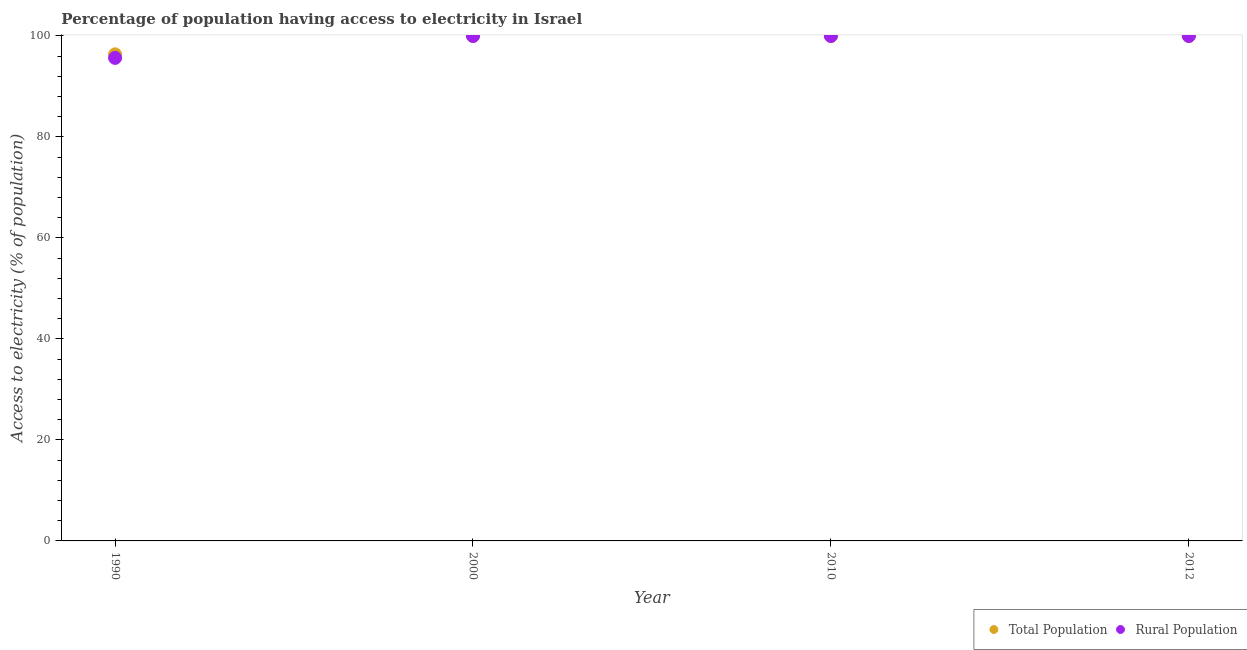How many different coloured dotlines are there?
Give a very brief answer. 2. Across all years, what is the minimum percentage of population having access to electricity?
Keep it short and to the point. 96.36. In which year was the percentage of rural population having access to electricity maximum?
Ensure brevity in your answer.  2000. What is the total percentage of population having access to electricity in the graph?
Provide a succinct answer. 396.36. What is the difference between the percentage of population having access to electricity in 2012 and the percentage of rural population having access to electricity in 2000?
Offer a terse response. 0. What is the average percentage of rural population having access to electricity per year?
Your answer should be very brief. 98.92. In the year 1990, what is the difference between the percentage of rural population having access to electricity and percentage of population having access to electricity?
Your response must be concise. -0.7. In how many years, is the percentage of rural population having access to electricity greater than 56 %?
Your answer should be very brief. 4. What is the difference between the highest and the lowest percentage of rural population having access to electricity?
Provide a succinct answer. 4.34. In how many years, is the percentage of population having access to electricity greater than the average percentage of population having access to electricity taken over all years?
Offer a terse response. 3. Does the percentage of rural population having access to electricity monotonically increase over the years?
Your response must be concise. No. Is the percentage of rural population having access to electricity strictly greater than the percentage of population having access to electricity over the years?
Your answer should be very brief. No. Are the values on the major ticks of Y-axis written in scientific E-notation?
Your answer should be compact. No. Does the graph contain grids?
Keep it short and to the point. No. How are the legend labels stacked?
Your answer should be very brief. Horizontal. What is the title of the graph?
Give a very brief answer. Percentage of population having access to electricity in Israel. What is the label or title of the Y-axis?
Your answer should be compact. Access to electricity (% of population). What is the Access to electricity (% of population) of Total Population in 1990?
Keep it short and to the point. 96.36. What is the Access to electricity (% of population) in Rural Population in 1990?
Provide a short and direct response. 95.66. What is the Access to electricity (% of population) of Total Population in 2000?
Make the answer very short. 100. What is the Access to electricity (% of population) in Rural Population in 2000?
Give a very brief answer. 100. What is the Access to electricity (% of population) in Total Population in 2010?
Provide a succinct answer. 100. What is the Access to electricity (% of population) of Rural Population in 2010?
Provide a succinct answer. 100. What is the Access to electricity (% of population) in Total Population in 2012?
Offer a very short reply. 100. What is the Access to electricity (% of population) in Rural Population in 2012?
Your answer should be very brief. 100. Across all years, what is the maximum Access to electricity (% of population) of Total Population?
Your answer should be compact. 100. Across all years, what is the minimum Access to electricity (% of population) in Total Population?
Make the answer very short. 96.36. Across all years, what is the minimum Access to electricity (% of population) in Rural Population?
Offer a very short reply. 95.66. What is the total Access to electricity (% of population) in Total Population in the graph?
Provide a succinct answer. 396.36. What is the total Access to electricity (% of population) of Rural Population in the graph?
Make the answer very short. 395.66. What is the difference between the Access to electricity (% of population) of Total Population in 1990 and that in 2000?
Offer a terse response. -3.64. What is the difference between the Access to electricity (% of population) of Rural Population in 1990 and that in 2000?
Your answer should be very brief. -4.34. What is the difference between the Access to electricity (% of population) of Total Population in 1990 and that in 2010?
Your response must be concise. -3.64. What is the difference between the Access to electricity (% of population) in Rural Population in 1990 and that in 2010?
Provide a short and direct response. -4.34. What is the difference between the Access to electricity (% of population) in Total Population in 1990 and that in 2012?
Make the answer very short. -3.64. What is the difference between the Access to electricity (% of population) of Rural Population in 1990 and that in 2012?
Keep it short and to the point. -4.34. What is the difference between the Access to electricity (% of population) in Total Population in 2000 and that in 2012?
Your answer should be very brief. 0. What is the difference between the Access to electricity (% of population) of Total Population in 1990 and the Access to electricity (% of population) of Rural Population in 2000?
Provide a succinct answer. -3.64. What is the difference between the Access to electricity (% of population) in Total Population in 1990 and the Access to electricity (% of population) in Rural Population in 2010?
Offer a very short reply. -3.64. What is the difference between the Access to electricity (% of population) in Total Population in 1990 and the Access to electricity (% of population) in Rural Population in 2012?
Your answer should be very brief. -3.64. What is the average Access to electricity (% of population) of Total Population per year?
Your answer should be very brief. 99.09. What is the average Access to electricity (% of population) in Rural Population per year?
Offer a very short reply. 98.92. In the year 1990, what is the difference between the Access to electricity (% of population) in Total Population and Access to electricity (% of population) in Rural Population?
Offer a terse response. 0.7. In the year 2000, what is the difference between the Access to electricity (% of population) in Total Population and Access to electricity (% of population) in Rural Population?
Provide a short and direct response. 0. In the year 2012, what is the difference between the Access to electricity (% of population) of Total Population and Access to electricity (% of population) of Rural Population?
Offer a very short reply. 0. What is the ratio of the Access to electricity (% of population) in Total Population in 1990 to that in 2000?
Your answer should be compact. 0.96. What is the ratio of the Access to electricity (% of population) in Rural Population in 1990 to that in 2000?
Make the answer very short. 0.96. What is the ratio of the Access to electricity (% of population) in Total Population in 1990 to that in 2010?
Provide a succinct answer. 0.96. What is the ratio of the Access to electricity (% of population) of Rural Population in 1990 to that in 2010?
Your answer should be compact. 0.96. What is the ratio of the Access to electricity (% of population) of Total Population in 1990 to that in 2012?
Give a very brief answer. 0.96. What is the ratio of the Access to electricity (% of population) of Rural Population in 1990 to that in 2012?
Keep it short and to the point. 0.96. What is the ratio of the Access to electricity (% of population) in Total Population in 2000 to that in 2010?
Make the answer very short. 1. What is the ratio of the Access to electricity (% of population) of Rural Population in 2000 to that in 2010?
Provide a succinct answer. 1. What is the ratio of the Access to electricity (% of population) in Total Population in 2000 to that in 2012?
Make the answer very short. 1. What is the ratio of the Access to electricity (% of population) of Rural Population in 2000 to that in 2012?
Provide a succinct answer. 1. What is the ratio of the Access to electricity (% of population) in Total Population in 2010 to that in 2012?
Make the answer very short. 1. What is the ratio of the Access to electricity (% of population) in Rural Population in 2010 to that in 2012?
Make the answer very short. 1. What is the difference between the highest and the second highest Access to electricity (% of population) of Total Population?
Your response must be concise. 0. What is the difference between the highest and the lowest Access to electricity (% of population) of Total Population?
Keep it short and to the point. 3.64. What is the difference between the highest and the lowest Access to electricity (% of population) in Rural Population?
Offer a very short reply. 4.34. 